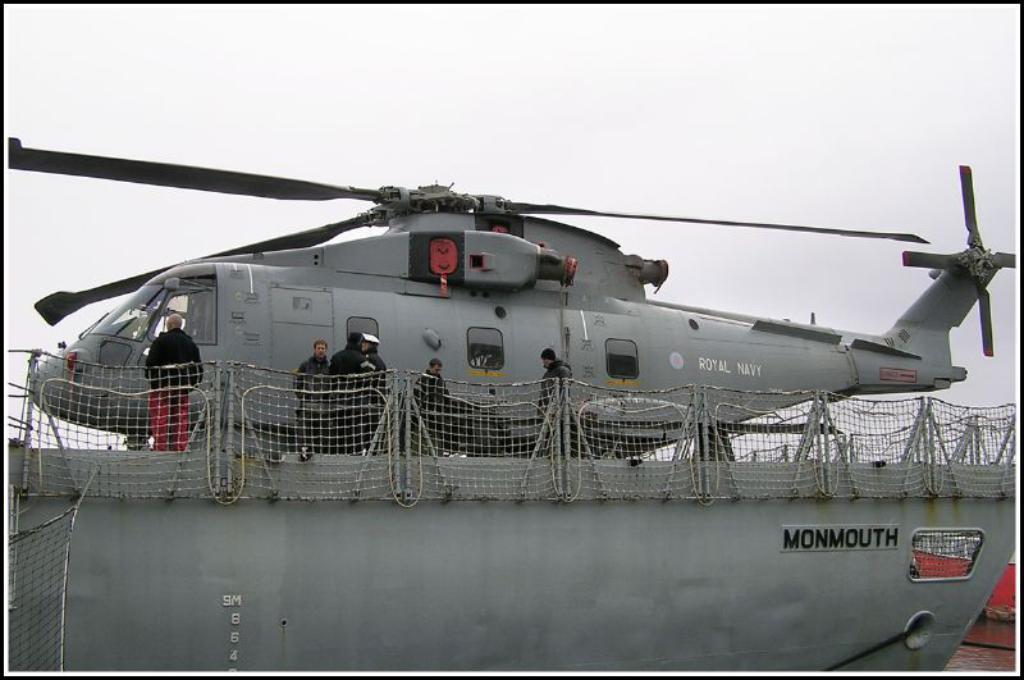What name is on the hull of this ship?
Give a very brief answer. Monmouth. What branch of military is cited on the helicopter?
Give a very brief answer. Royal navy. 